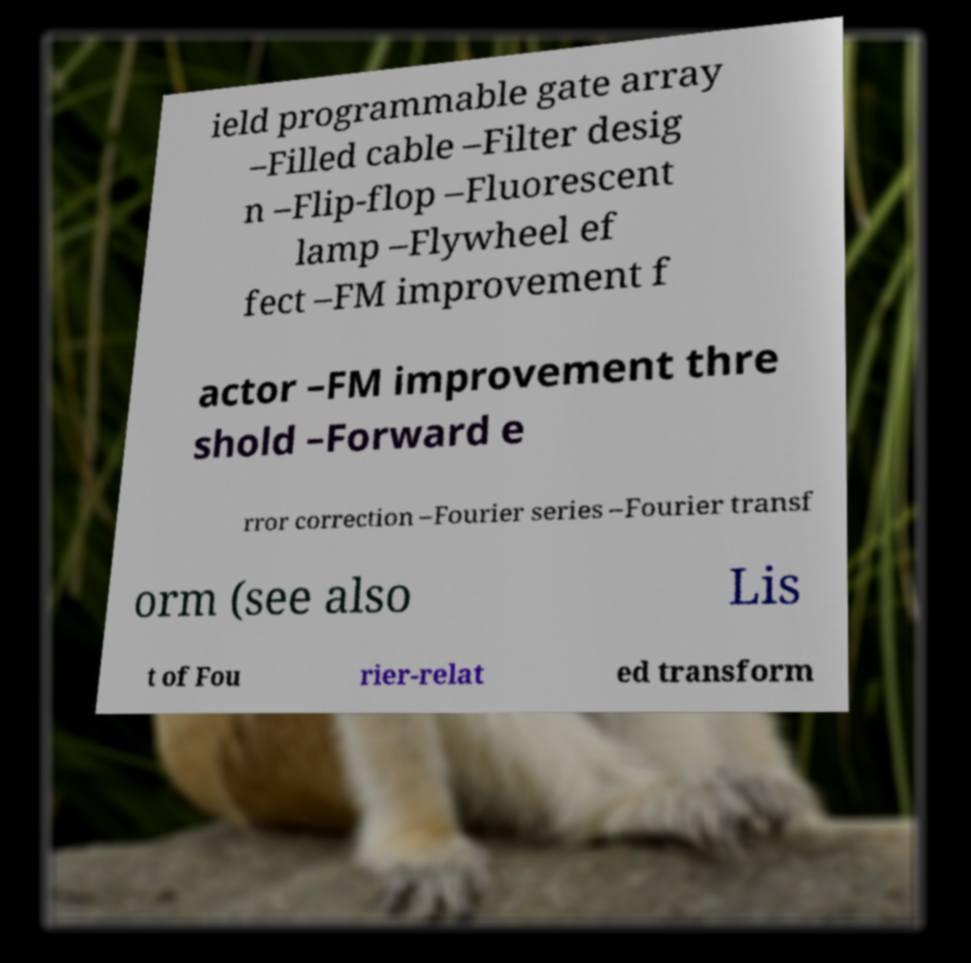There's text embedded in this image that I need extracted. Can you transcribe it verbatim? ield programmable gate array –Filled cable –Filter desig n –Flip-flop –Fluorescent lamp –Flywheel ef fect –FM improvement f actor –FM improvement thre shold –Forward e rror correction –Fourier series –Fourier transf orm (see also Lis t of Fou rier-relat ed transform 